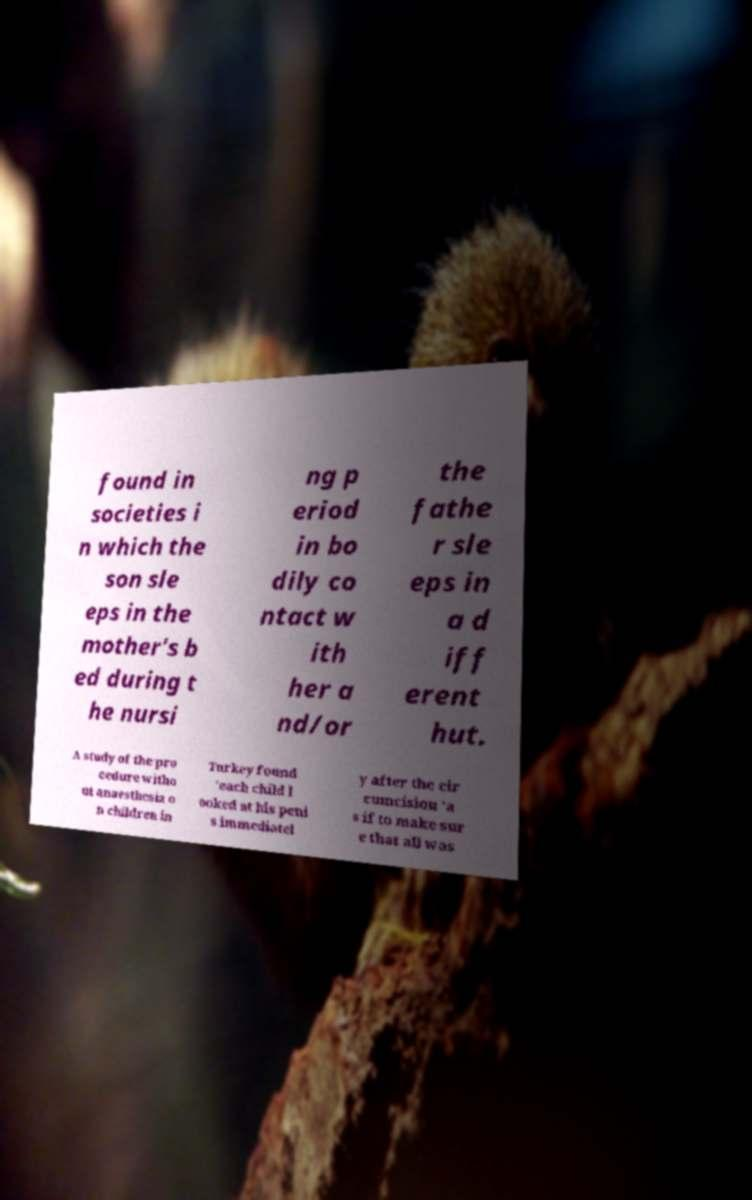Can you accurately transcribe the text from the provided image for me? found in societies i n which the son sle eps in the mother's b ed during t he nursi ng p eriod in bo dily co ntact w ith her a nd/or the fathe r sle eps in a d iff erent hut. A study of the pro cedure witho ut anaesthesia o n children in Turkey found 'each child l ooked at his peni s immediatel y after the cir cumcision 'a s if to make sur e that all was 